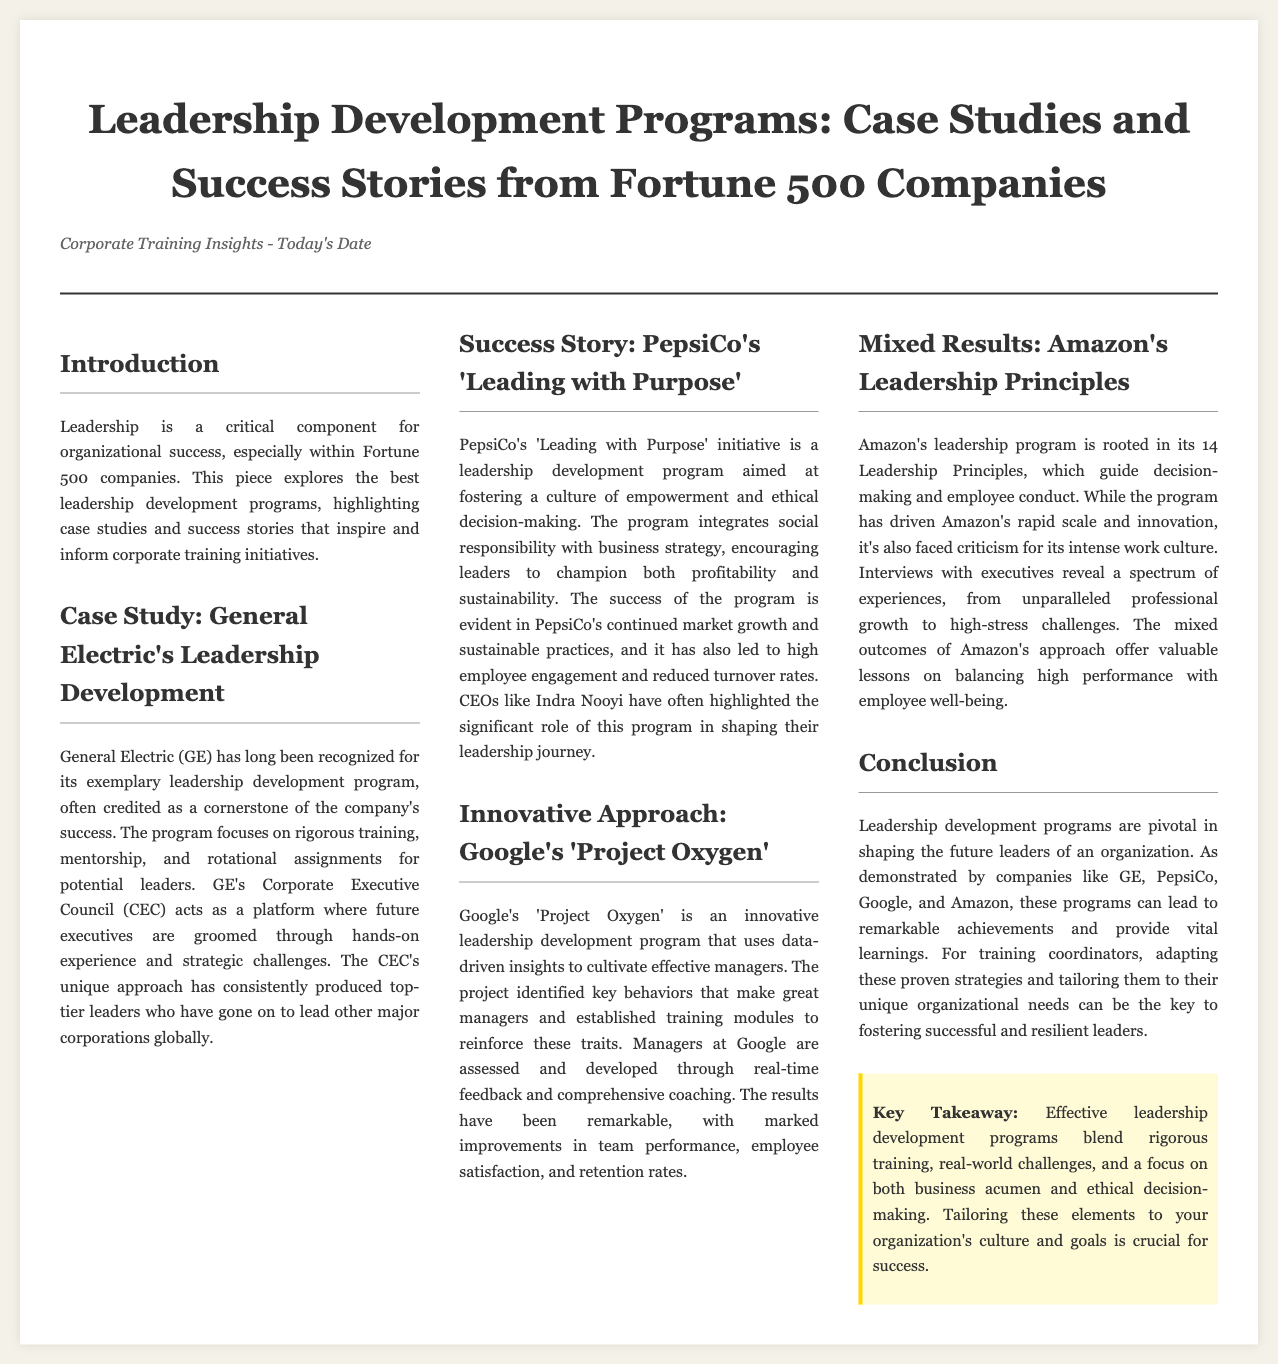What is the title of the article? The title of the article is prominently displayed at the top of the document.
Answer: Leadership Development Programs: Case Studies and Success Stories from Fortune 500 Companies Who is mentioned as a leader associated with PepsiCo’s program? The document cites a specific leader associated with PepsiCo's initiative.
Answer: Indra Nooyi What program does Google implement for leadership development? The document specifies the name of the program used by Google for leadership development.
Answer: Project Oxygen How many Leadership Principles does Amazon have? The document states the number of principles that guide Amazon's leadership program.
Answer: 14 What does GE's program focus on? The document describes the primary focus of General Electric's leadership development program.
Answer: Rigorous training, mentorship, and rotational assignments What kind of approach does PepsiCo's program integrate? The focus of PepsiCo's program as stated in the document can be captured in a specific term.
Answer: Social responsibility with business strategy What is a key takeaway from the article? The document concludes with an important takeaway related to leadership development programs.
Answer: Effective leadership development programs blend rigorous training, real-world challenges, and a focus on both business acumen and ethical decision-making 